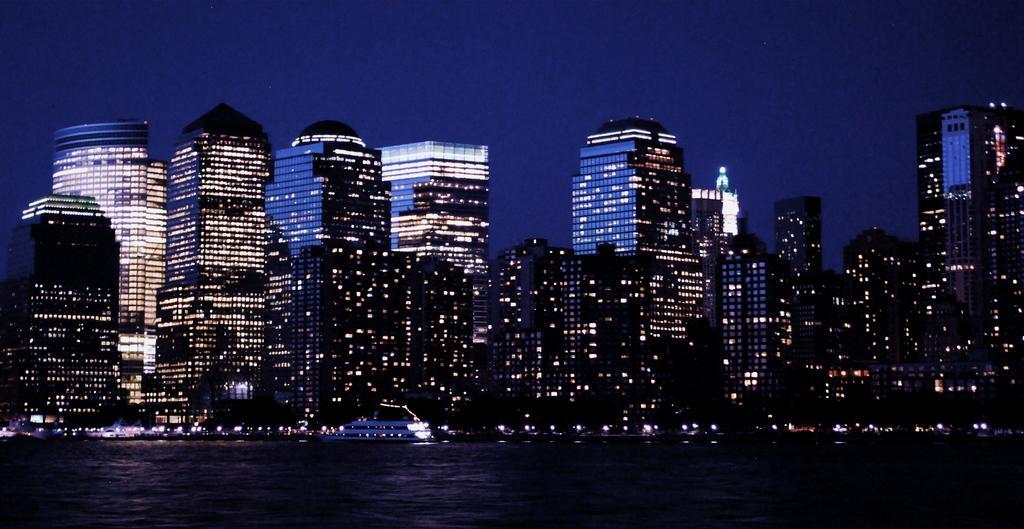In one or two sentences, can you explain what this image depicts? In this image I can see the water, a ship which is white in color on the surface of the water and few other boats. In the background I can see few buildings, few lights and the sky. 